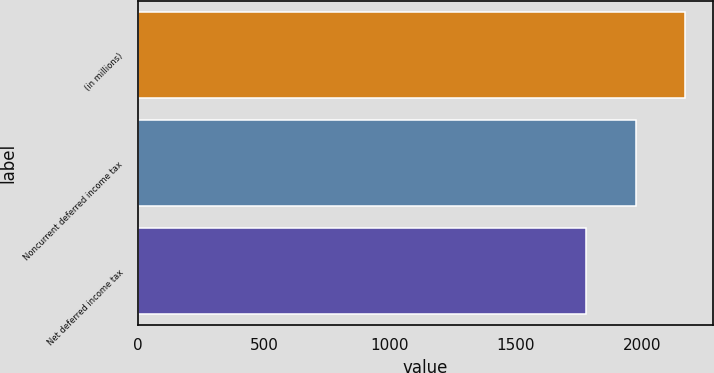Convert chart. <chart><loc_0><loc_0><loc_500><loc_500><bar_chart><fcel>(in millions)<fcel>Noncurrent deferred income tax<fcel>Net deferred income tax<nl><fcel>2173.2<fcel>1975.1<fcel>1777<nl></chart> 